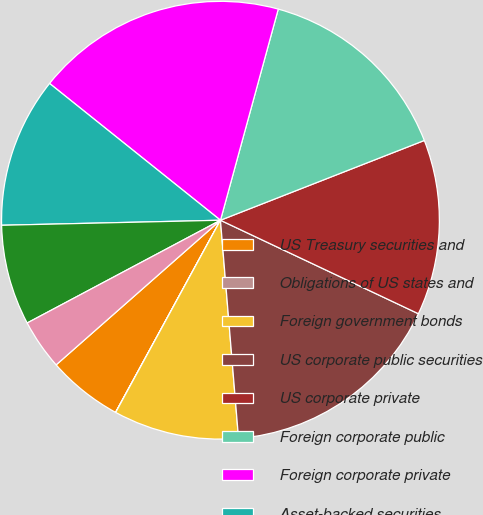<chart> <loc_0><loc_0><loc_500><loc_500><pie_chart><fcel>US Treasury securities and<fcel>Obligations of US states and<fcel>Foreign government bonds<fcel>US corporate public securities<fcel>US corporate private<fcel>Foreign corporate public<fcel>Foreign corporate private<fcel>Asset-backed securities<fcel>Commercial mortgage-backed<fcel>Residential mortgage-backed<nl><fcel>5.56%<fcel>0.01%<fcel>9.26%<fcel>16.66%<fcel>12.96%<fcel>14.81%<fcel>18.51%<fcel>11.11%<fcel>7.41%<fcel>3.71%<nl></chart> 